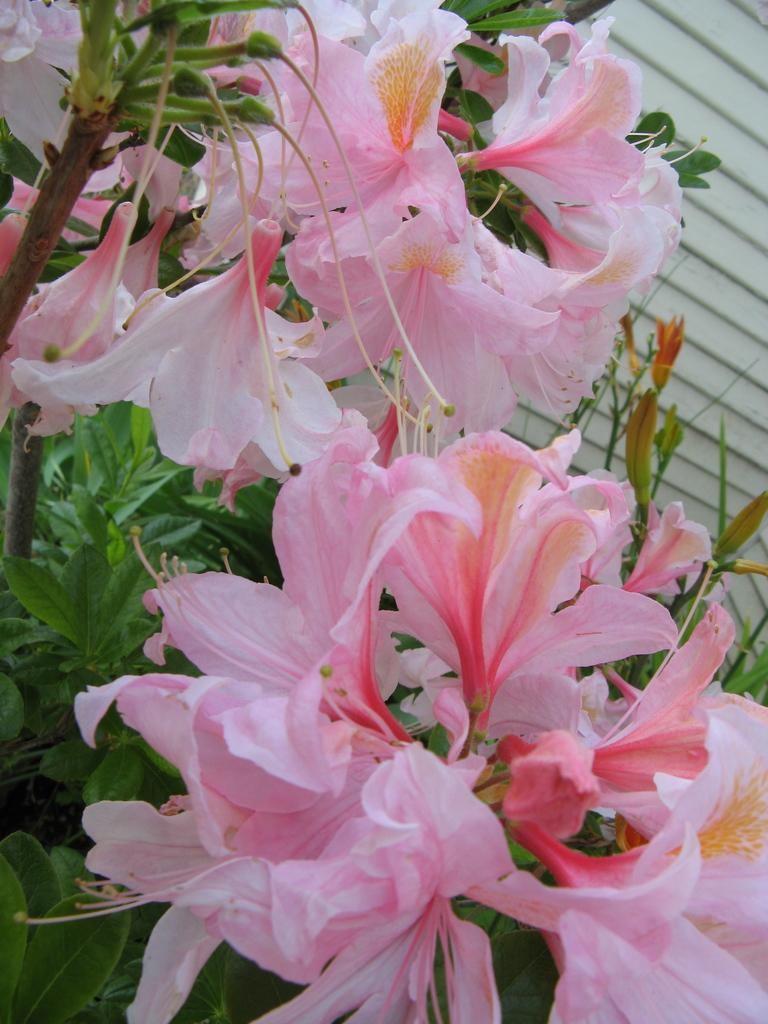What type of plants are present in the image? There are plants with pink flowers in the image. What can be seen behind the plants in the image? There is a wall visible at the back side of the image. What is the woman doing with her hand in the image? There is no woman present in the image, so this question cannot be answered. 